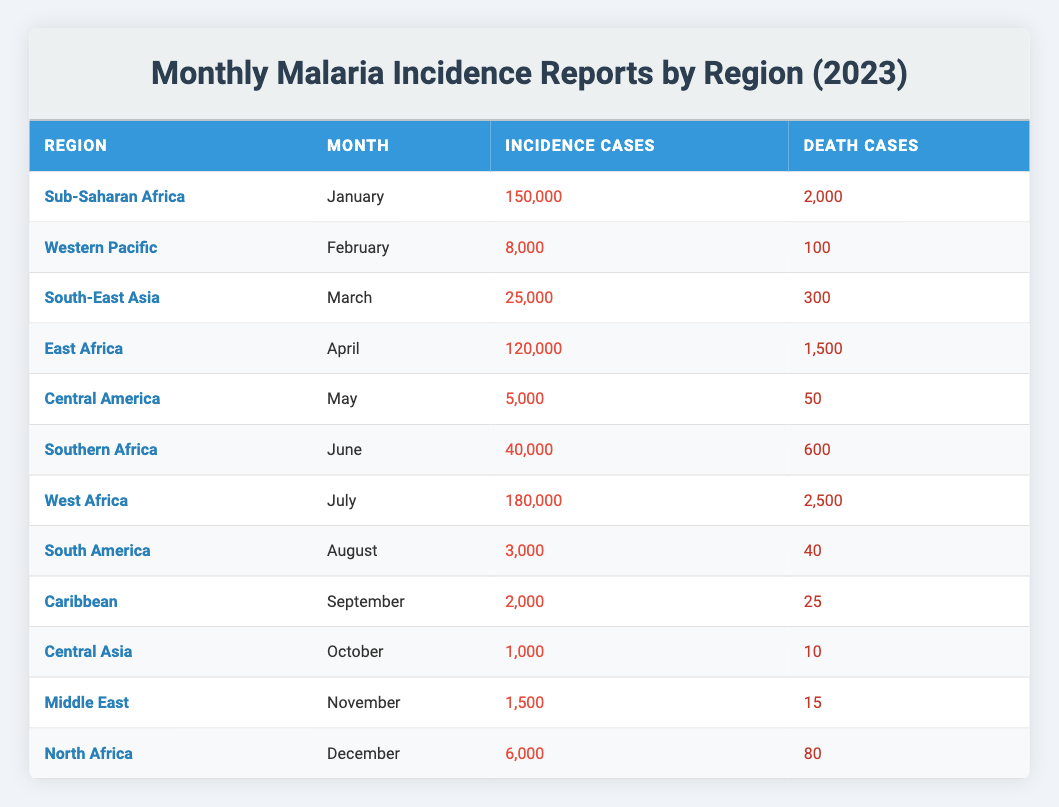What is the total number of malaria incidence cases reported in July 2023? From the table, we can find that in July 2023, the region reported 180,000 incidence cases.
Answer: 180000 Which region reported the least number of death cases in its malaria incidence report for 2023? By inspecting the "Death Cases" column in the table, the region with the least number of death cases is Central Asia with 10 cases in October.
Answer: Central Asia What is the total number of incidence cases reported in the first half of 2023 (January to June)? We add the incidence cases from January (150,000), February (8,000), March (25,000), April (120,000), May (5,000), and June (40,000). The total is: 150,000 + 8,000 + 25,000 + 120,000 + 5,000 + 40,000 = 348,000.
Answer: 348000 Is the number of death cases in South America higher than in Central America? Looking at the table, South America has 40 death cases in August, while Central America has 50 death cases in May. Hence, 40 is not greater than 50, so the answer is false.
Answer: False What is the average number of death cases reported across all regions in 2023? First, we must sum all the death cases listed: 2,000 (Sub-Saharan Africa) + 100 (Western Pacific) + 300 (South-East Asia) + 1,500 (East Africa) + 50 (Central America) + 600 (Southern Africa) + 2,500 (West Africa) + 40 (South America) + 25 (Caribbean) + 10 (Central Asia) + 15 (Middle East) + 80 (North Africa) = 7,220. Then, divide this by 12 (the number of regions): 7,220 / 12 = 601.67, which can be rounded to 602 for whole cases.
Answer: 602 How many more malaria incidence cases were reported in Sub-Saharan Africa compared to the Western Pacific in 2023? In the table, Sub-Saharan Africa reported 150,000 incidence cases in January, and the Western Pacific had 8,000 cases in February. The difference is: 150,000 - 8,000 = 142,000 cases.
Answer: 142000 